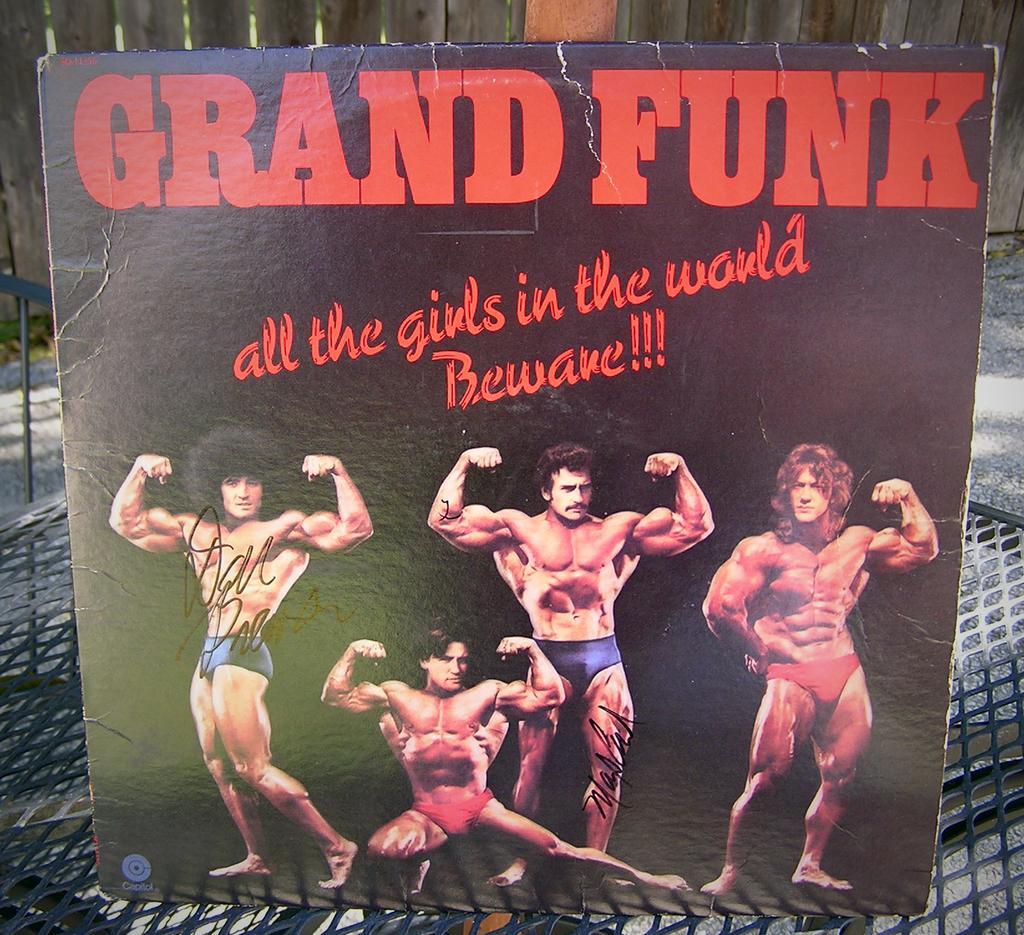How would you summarize this image in a sentence or two? In this image I can see a black color board which is placed on a net. On this board I can see some text in red color and also I can see the images of four men. Three are standing and one is sitting. On the top of the image there is a fencing and I can see the ground. 